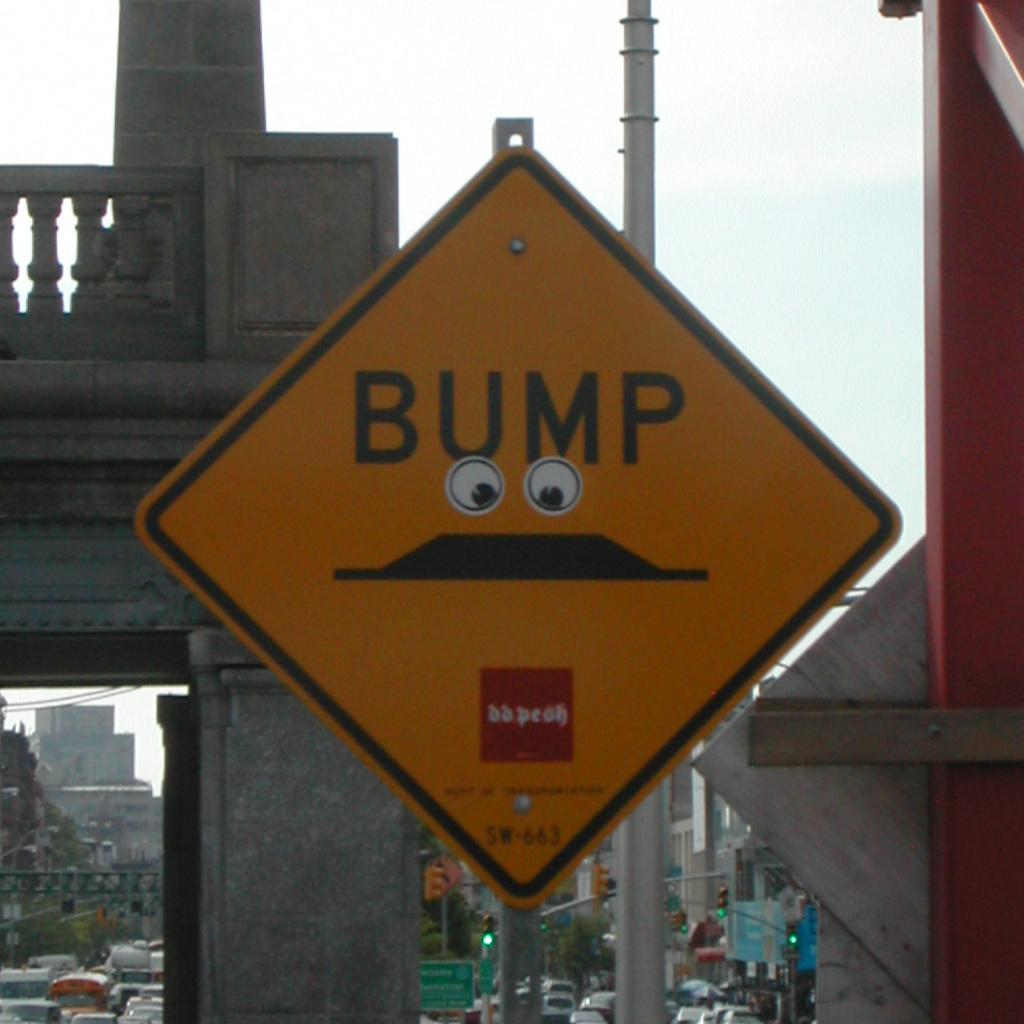<image>
Share a concise interpretation of the image provided. A yellow sign says "bump" on it in black text. 